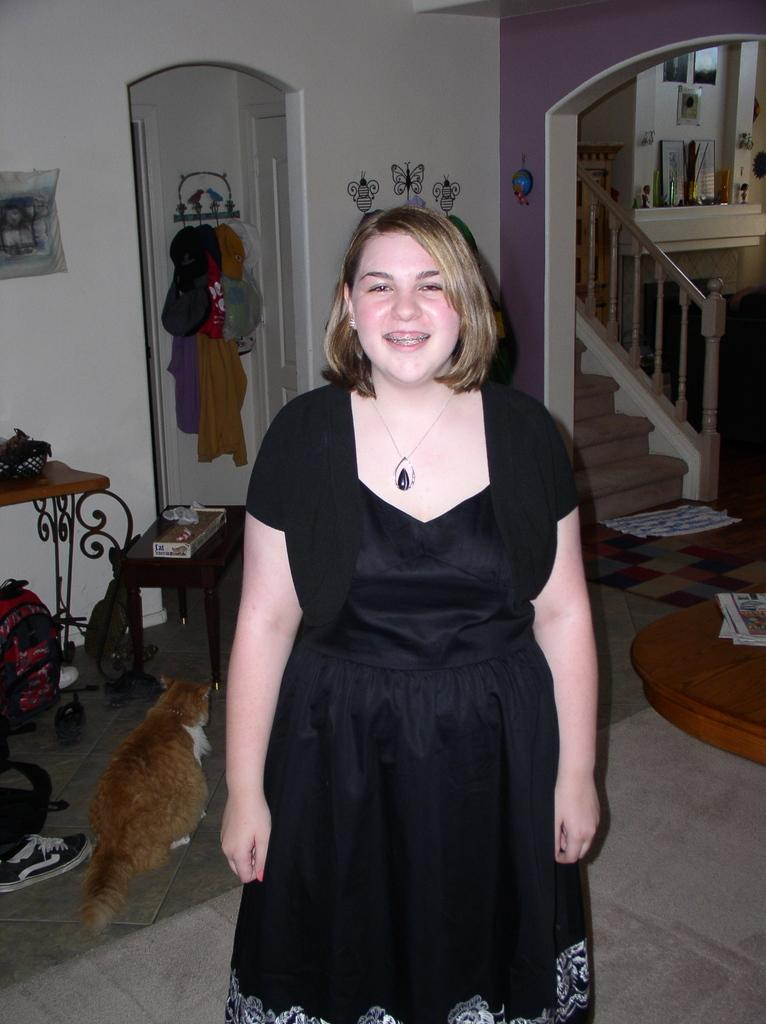Who is the main subject in the image? There is a lady in the image. What is the lady wearing? The lady is wearing a black gown. Can you describe the lady's hairstyle? The lady has short hair. What can be seen behind the lady? There is a cat behind the lady. What type of furniture is present in the image? There is a desk in the image. What is placed on the desk? There are things placed on the desk. What architectural feature is visible in the image? There is a staircase in the image. What is placed near the staircase? There are things placed near the staircase. What type of yak can be seen in the image? There is no yak present in the image. 